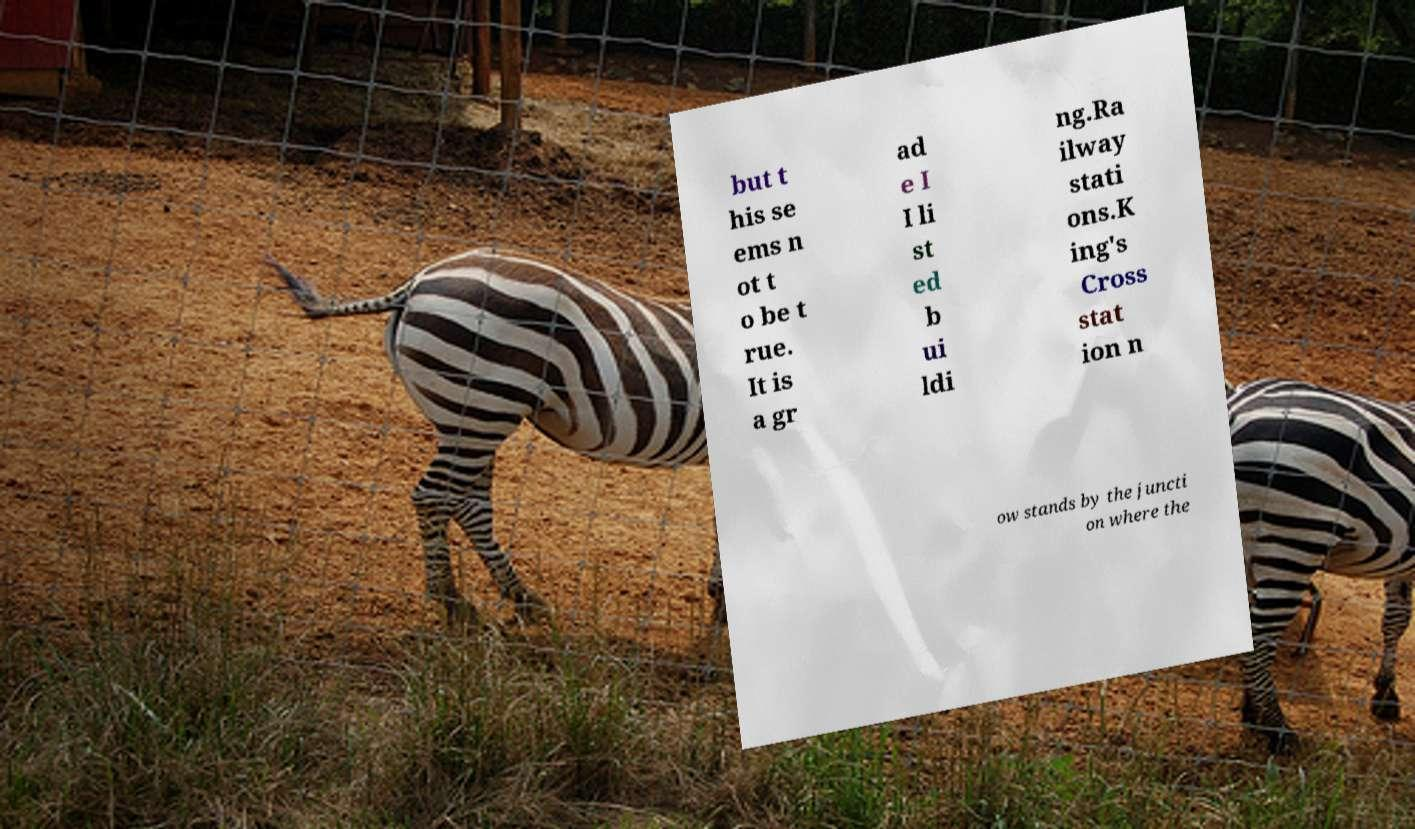Can you accurately transcribe the text from the provided image for me? but t his se ems n ot t o be t rue. It is a gr ad e I I li st ed b ui ldi ng.Ra ilway stati ons.K ing's Cross stat ion n ow stands by the juncti on where the 